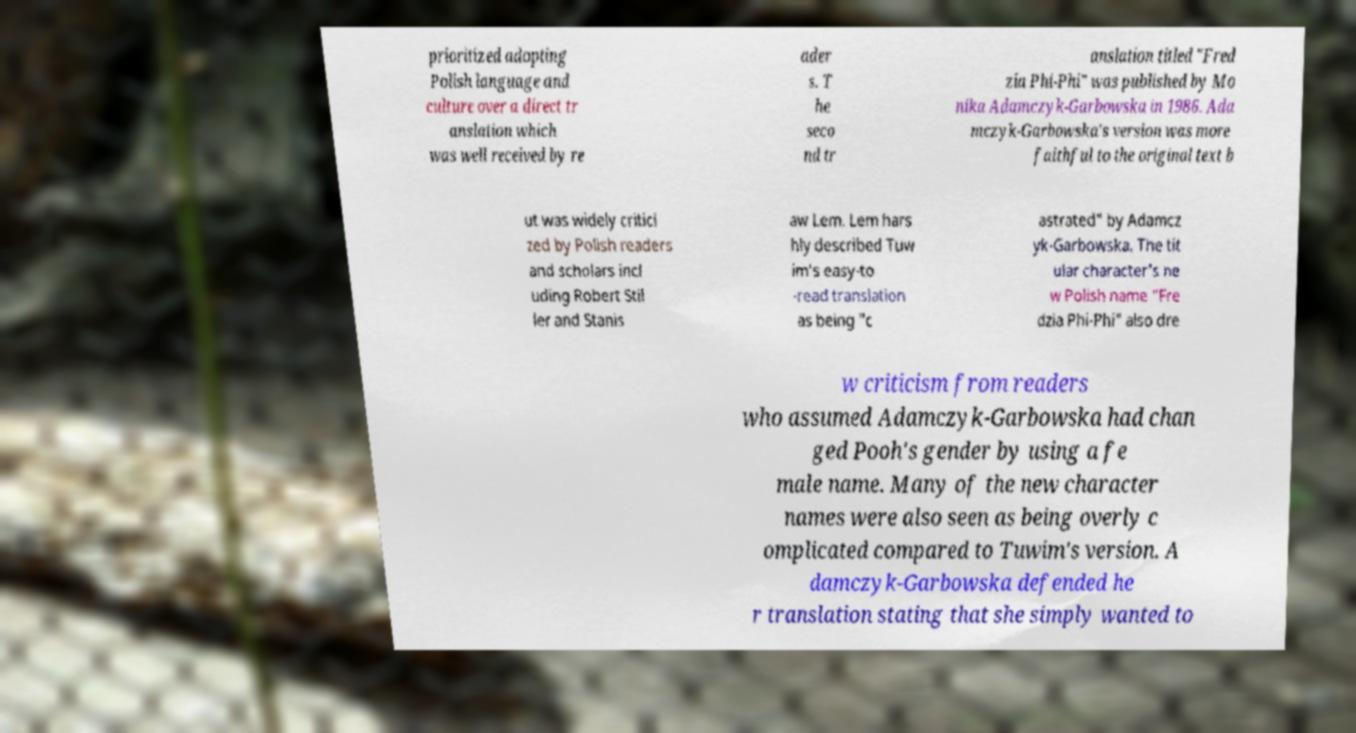Could you assist in decoding the text presented in this image and type it out clearly? prioritized adopting Polish language and culture over a direct tr anslation which was well received by re ader s. T he seco nd tr anslation titled "Fred zia Phi-Phi" was published by Mo nika Adamczyk-Garbowska in 1986. Ada mczyk-Garbowska's version was more faithful to the original text b ut was widely critici zed by Polish readers and scholars incl uding Robert Stil ler and Stanis aw Lem. Lem hars hly described Tuw im's easy-to -read translation as being "c astrated" by Adamcz yk-Garbowska. The tit ular character's ne w Polish name "Fre dzia Phi-Phi" also dre w criticism from readers who assumed Adamczyk-Garbowska had chan ged Pooh's gender by using a fe male name. Many of the new character names were also seen as being overly c omplicated compared to Tuwim's version. A damczyk-Garbowska defended he r translation stating that she simply wanted to 